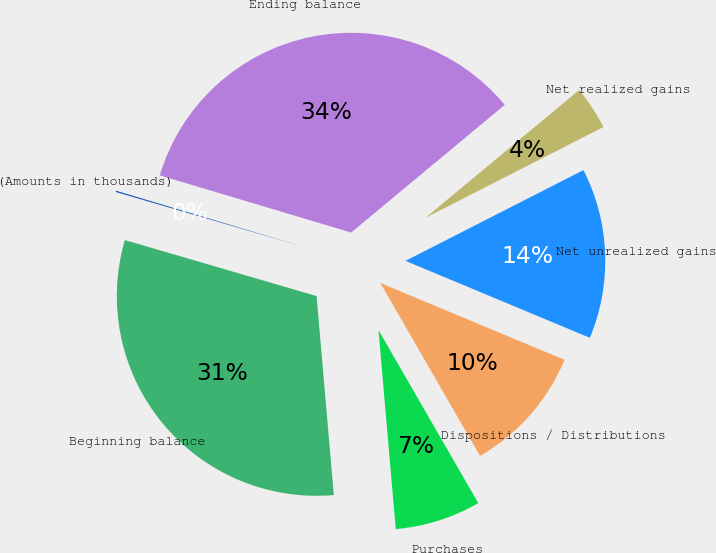<chart> <loc_0><loc_0><loc_500><loc_500><pie_chart><fcel>(Amounts in thousands)<fcel>Beginning balance<fcel>Purchases<fcel>Dispositions / Distributions<fcel>Net unrealized gains<fcel>Net realized gains<fcel>Ending balance<nl><fcel>0.1%<fcel>30.9%<fcel>6.95%<fcel>10.38%<fcel>13.8%<fcel>3.53%<fcel>34.34%<nl></chart> 